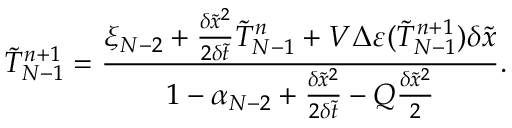Convert formula to latex. <formula><loc_0><loc_0><loc_500><loc_500>\tilde { T } _ { N - 1 } ^ { n + 1 } = \frac { { { \xi _ { N - 2 } } + \frac { { \delta { { \tilde { x } } ^ { 2 } } } } { { 2 \delta \tilde { t } } } \tilde { T } _ { N - 1 } ^ { n } + V \Delta \varepsilon ( \tilde { T } _ { N - 1 } ^ { n + 1 } ) \delta \tilde { x } } } { { 1 - { \alpha _ { N - 2 } } + \frac { { \delta { { \tilde { x } } ^ { 2 } } } } { { 2 \delta \tilde { t } } } - Q \frac { { \delta { { \tilde { x } } ^ { 2 } } } } { 2 } } } .</formula> 